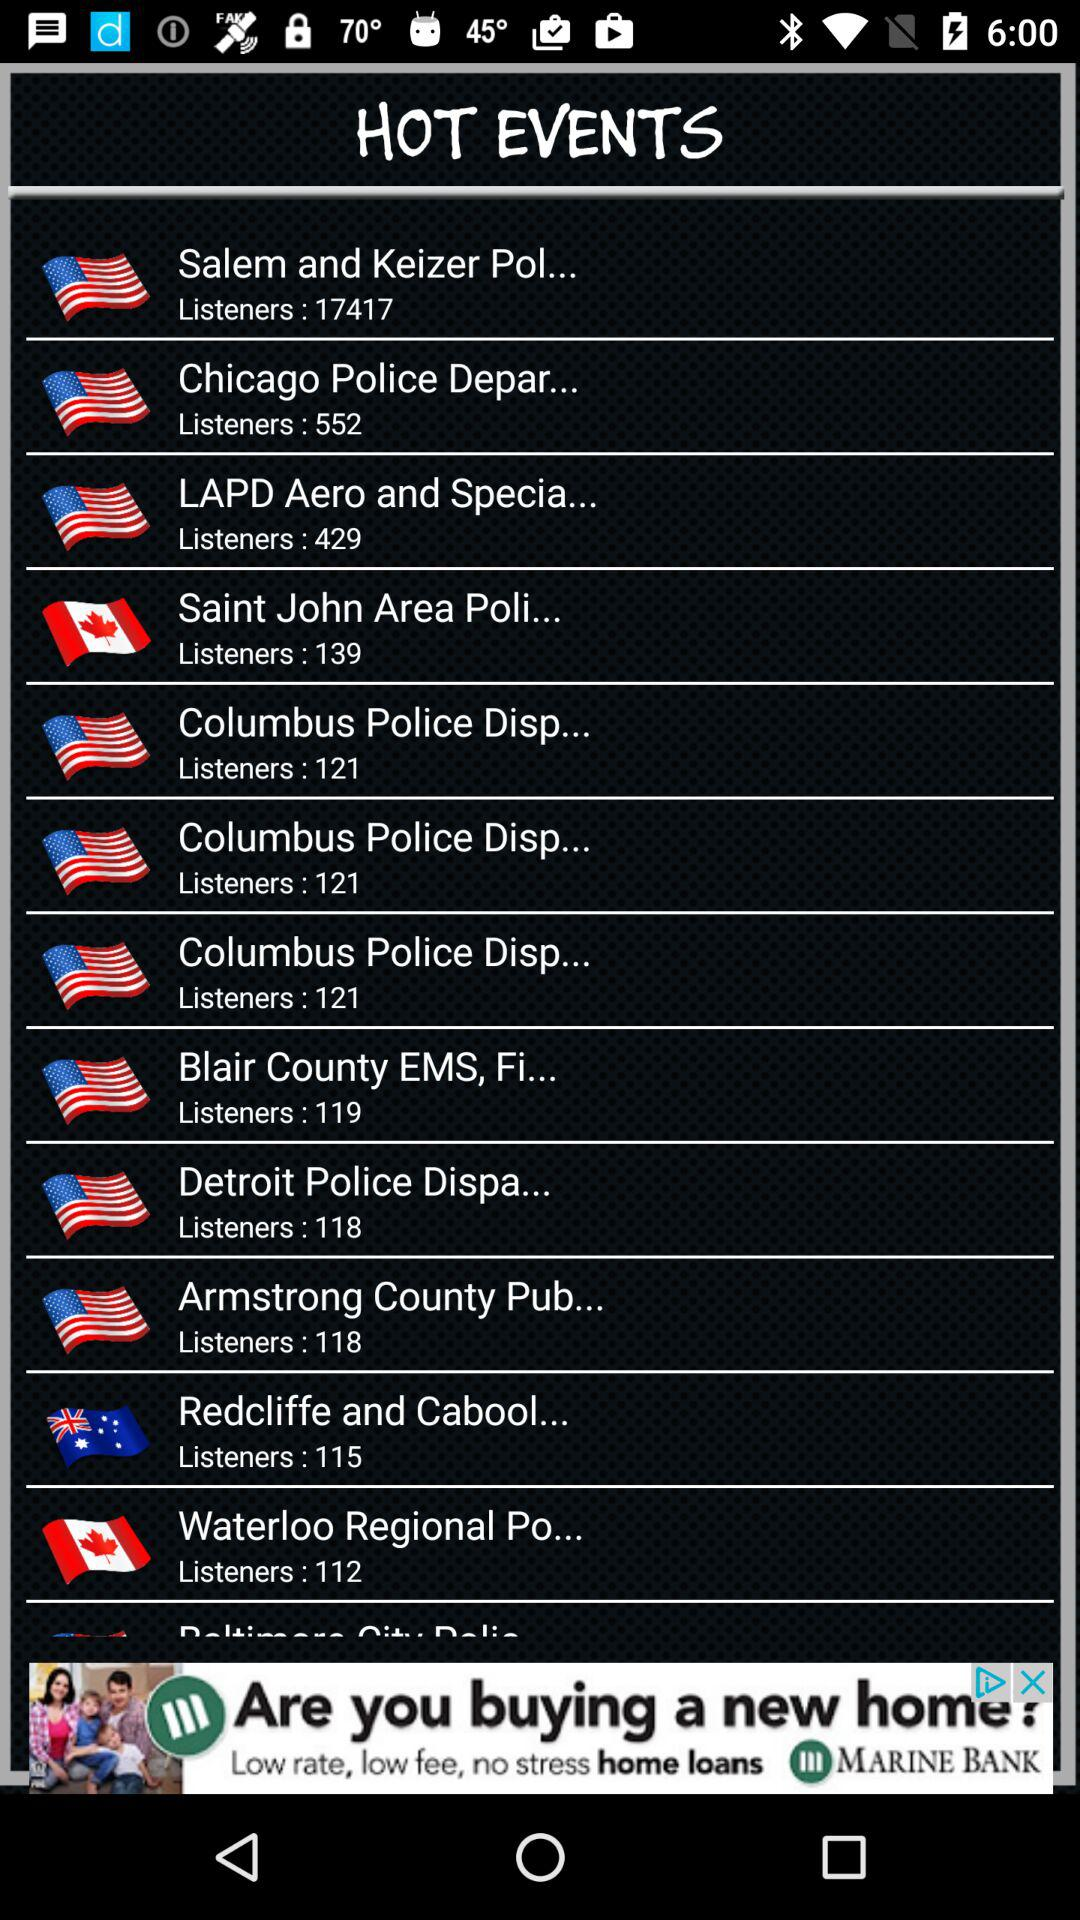What is the number of "Chicago Police Department" listeners? The number of "Chicago Police Department" listeners is 552. 